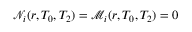Convert formula to latex. <formula><loc_0><loc_0><loc_500><loc_500>\ m a t h s c r { N } _ { i } ( r , T _ { 0 } , T _ { 2 } ) = \ m a t h s c r { M } _ { i } ( r , T _ { 0 } , T _ { 2 } ) = 0</formula> 